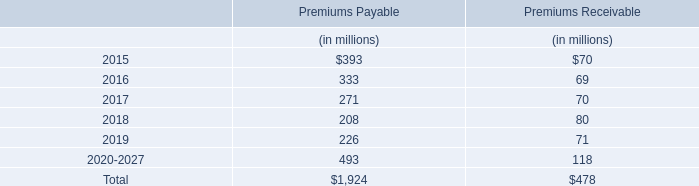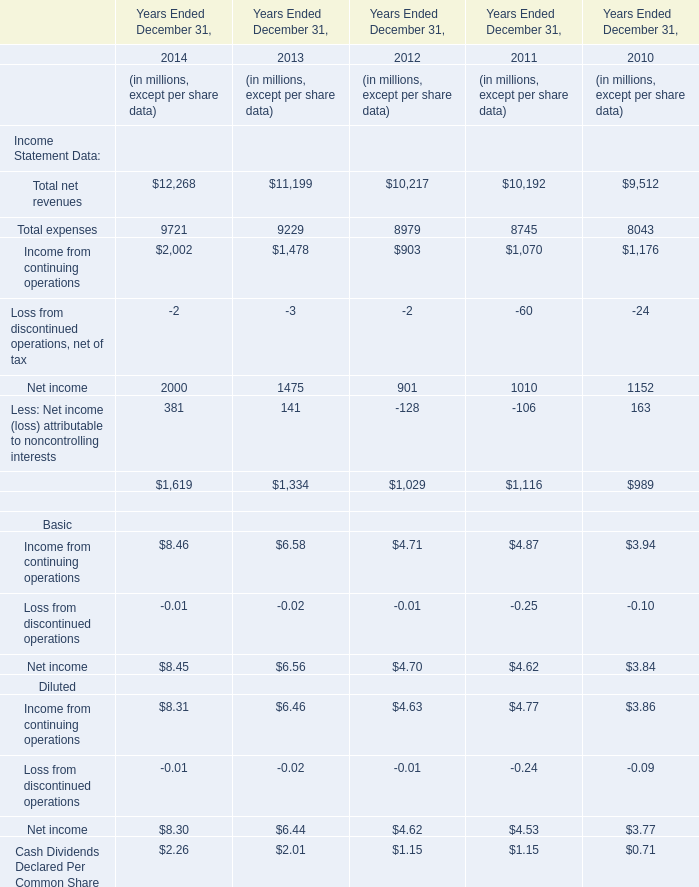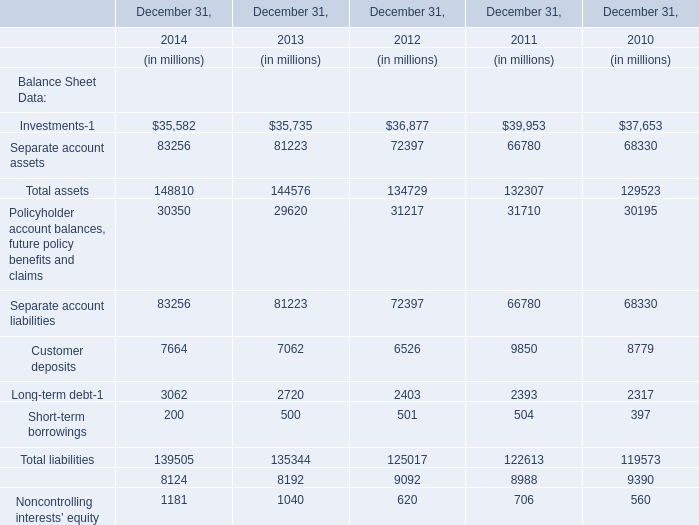What's the total amount of Income Statement Data excluding Total net revenues and Total expenses in 2014? (in million) 
Computations: ((((2002 - 2) + 2000) + 381) + 1619)
Answer: 6000.0. 